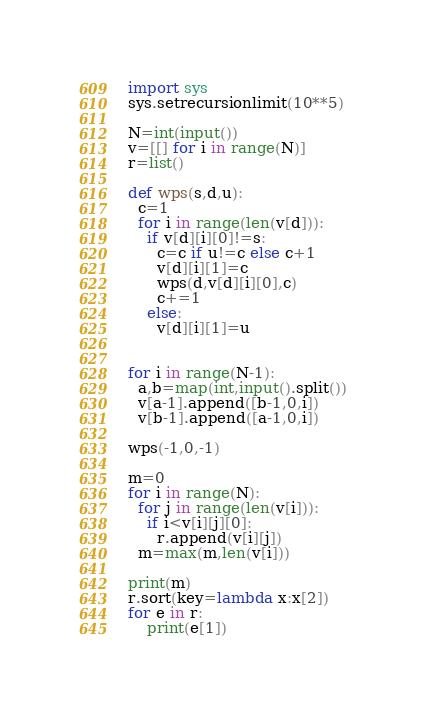Convert code to text. <code><loc_0><loc_0><loc_500><loc_500><_Python_>import sys
sys.setrecursionlimit(10**5)

N=int(input())
v=[[] for i in range(N)]
r=list()

def wps(s,d,u):
  c=1
  for i in range(len(v[d])):
    if v[d][i][0]!=s:
      c=c if u!=c else c+1
      v[d][i][1]=c
      wps(d,v[d][i][0],c)
      c+=1
    else:
      v[d][i][1]=u


for i in range(N-1):
  a,b=map(int,input().split())
  v[a-1].append([b-1,0,i])
  v[b-1].append([a-1,0,i])

wps(-1,0,-1)

m=0
for i in range(N):
  for j in range(len(v[i])):
    if i<v[i][j][0]:
      r.append(v[i][j])
  m=max(m,len(v[i]))

print(m)
r.sort(key=lambda x:x[2])
for e in r:
	print(e[1])
</code> 